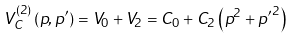<formula> <loc_0><loc_0><loc_500><loc_500>V ^ { ( 2 ) } _ { C } \left ( { p } , { { p } ^ { \prime } } \right ) = V _ { 0 } + V _ { 2 } = C _ { 0 } + C _ { 2 } \left ( { p } ^ { 2 } + { p ^ { \prime } } ^ { 2 } \right )</formula> 